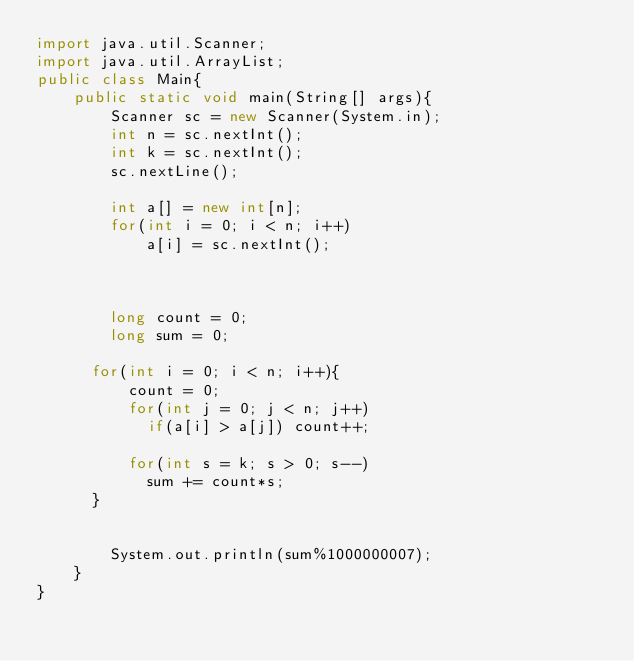Convert code to text. <code><loc_0><loc_0><loc_500><loc_500><_Java_>import java.util.Scanner;
import java.util.ArrayList;
public class Main{
	public static void main(String[] args){
		Scanner sc = new Scanner(System.in);
		int n = sc.nextInt();
      	int k = sc.nextInt();
      	sc.nextLine();
      	
      	int a[] = new int[n];
      	for(int i = 0; i < n; i++)
        	a[i] = sc.nextInt();
      

      
      	long count = 0;
      	long sum = 0;
      
      for(int i = 0; i < n; i++){
          count = 0;
          for(int j = 0; j < n; j++)
            if(a[i] > a[j]) count++;
      
          for(int s = k; s > 0; s--)
          	sum += count*s;
      }
      	

		System.out.println(sum%1000000007);
	}
}</code> 